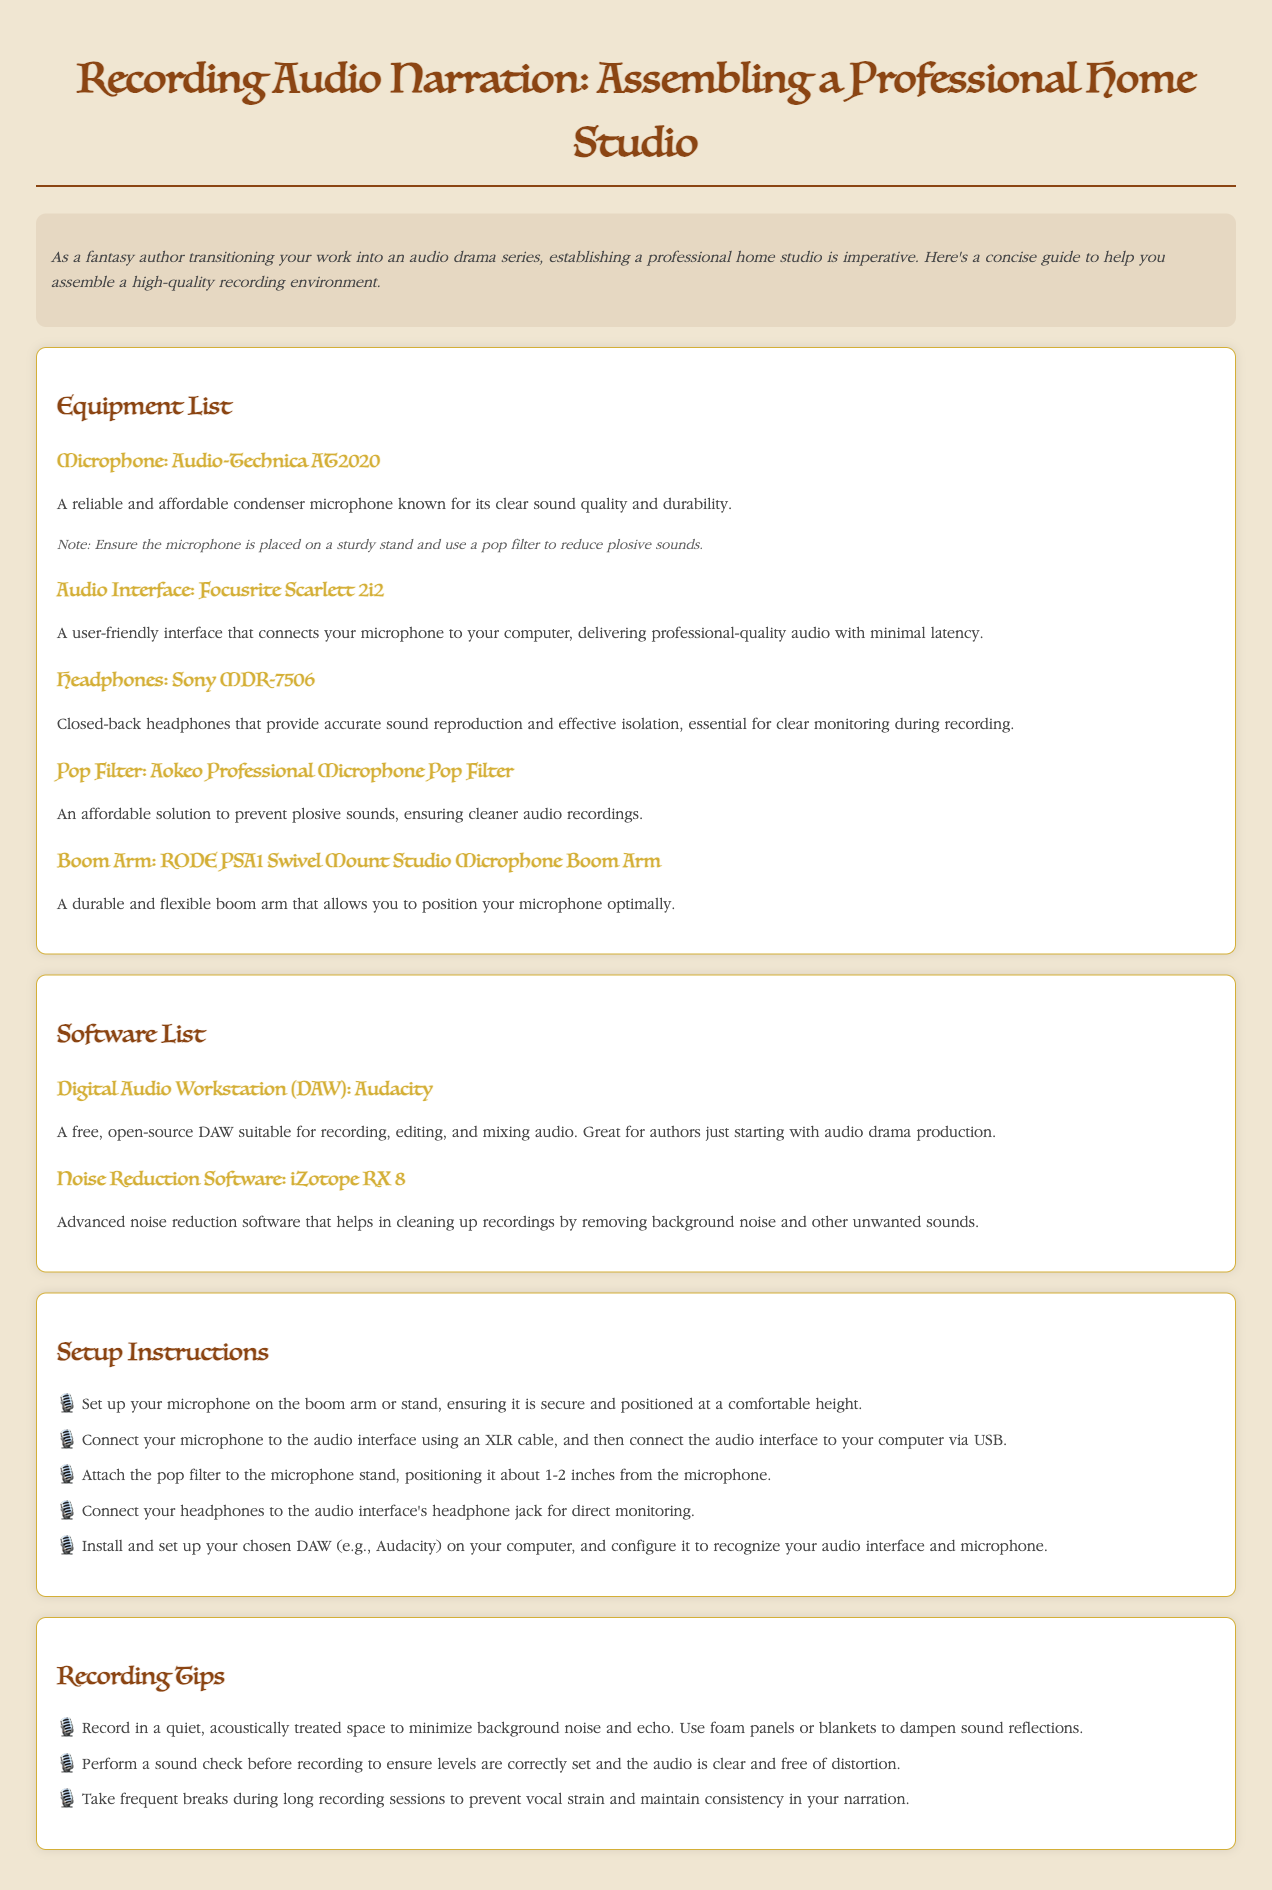What is the title of the document? The title is clearly stated at the top of the document, highlighting the focus on assembling a home studio for audio narration.
Answer: Recording Audio Narration: Assembling a Professional Home Studio What microphone is recommended in the equipment list? The equipment list specifies the Audio-Technica AT2020 as a recommended microphone for recording.
Answer: Audio-Technica AT2020 How many setup instructions are provided in the document? The setup instructions are listed in an ordered format, and counting them gives the total number of instructions provided.
Answer: Five What is the primary function of iZotope RX 8 software? The software section describes iZotope RX 8 as advanced noise reduction software aimed at cleaning up recordings by removing background noise.
Answer: Noise reduction What type of headphones are suggested for recording? The equipment section lists specific headphones, naming the model suited for accurate sound reproduction and isolation.
Answer: Sony MDR-7506 What is one tip given for during long recording sessions? The recording tips section provides advice on maintaining vocal health and consistency during lengthy recording activities.
Answer: Take frequent breaks What color is the document's background? A description of the body style indicates the color used in the document's background for visual appeal.
Answer: Light beige Which DAW is mentioned as suitable for beginners? The software section specifically names a Digital Audio Workstation that is free and suitable for those starting in audio drama production.
Answer: Audacity What should be used to prevent plosive sounds when recording? The equipment list suggests a specific item that serves to reduce plosive noises during voice recordings.
Answer: Pop Filter 